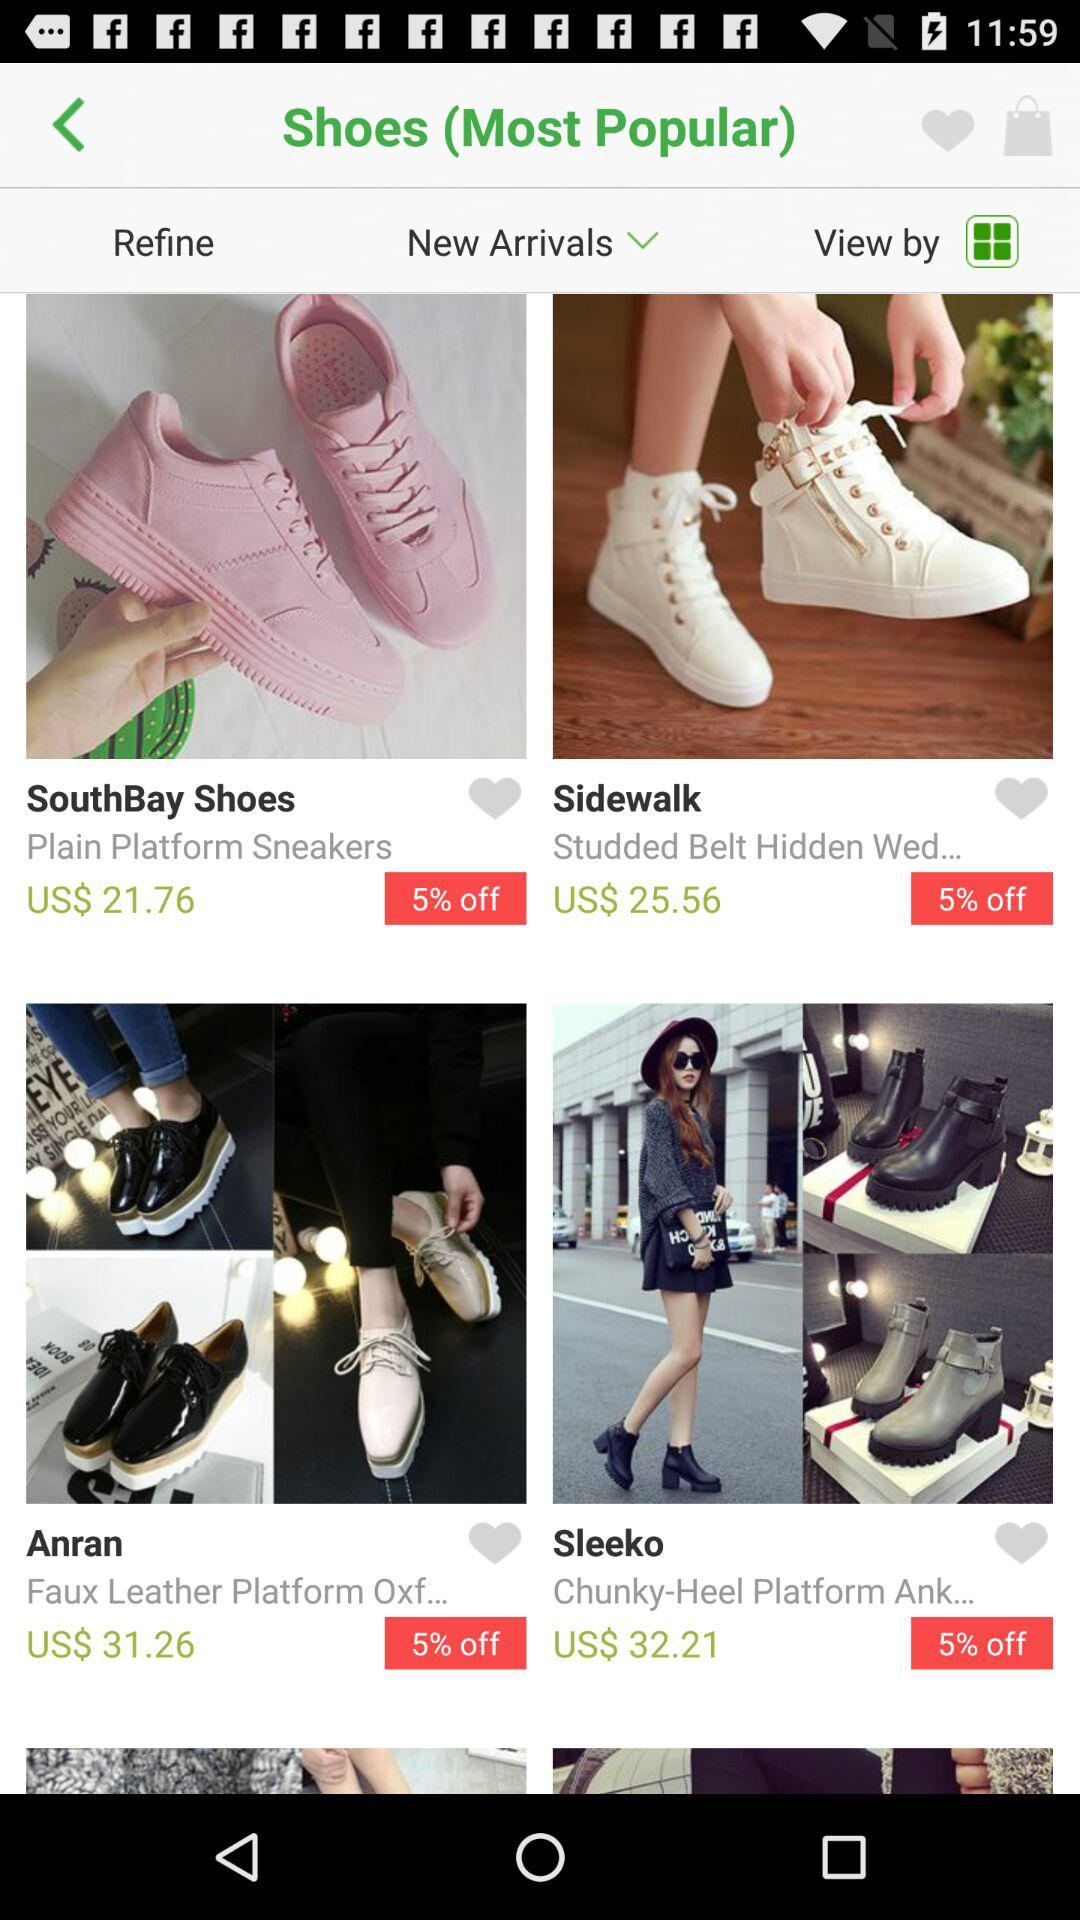What's the cost of "Sidewalk" shoes? The cost of the Sidewalk shoes is US$ 25.56. 